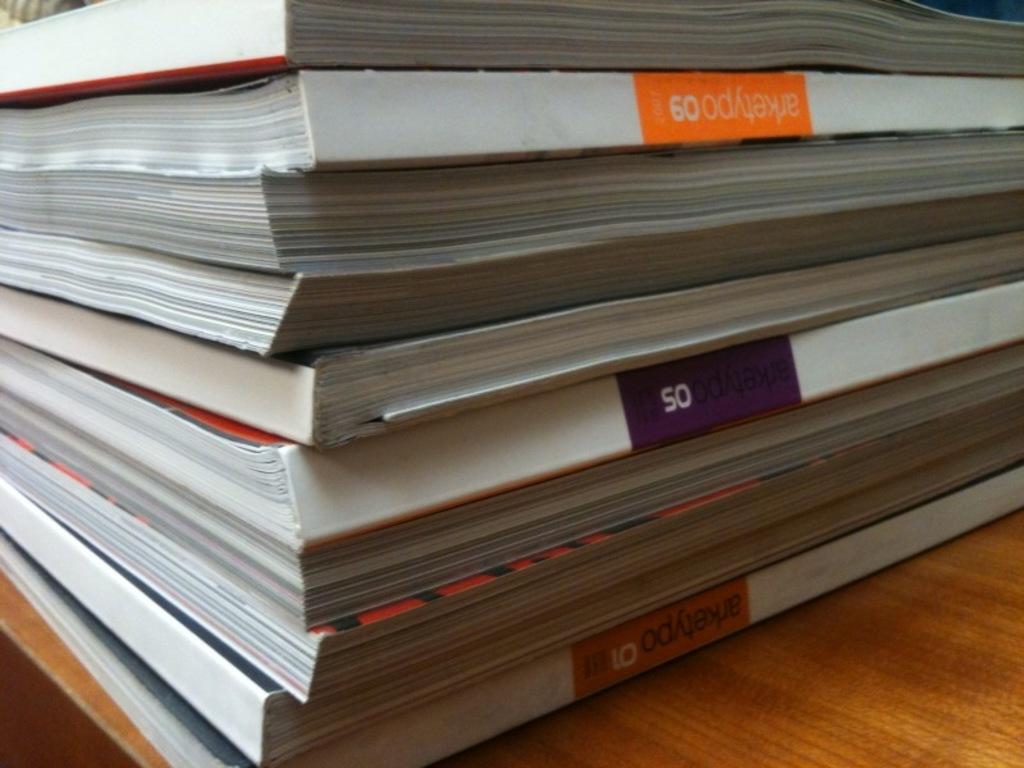What is the name of the magazine in the stack?
Keep it short and to the point. Arketypo. What does it say in the purple box?
Offer a terse response. 50. 